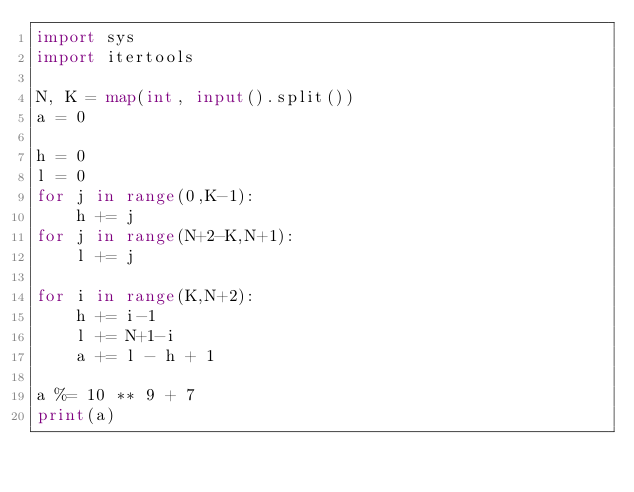<code> <loc_0><loc_0><loc_500><loc_500><_Python_>import sys
import itertools

N, K = map(int, input().split())
a = 0

h = 0
l = 0
for j in range(0,K-1):
    h += j
for j in range(N+2-K,N+1):
    l += j

for i in range(K,N+2):
    h += i-1
    l += N+1-i
    a += l - h + 1

a %= 10 ** 9 + 7
print(a)

</code> 